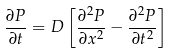Convert formula to latex. <formula><loc_0><loc_0><loc_500><loc_500>\frac { \partial P } { \partial t } = D \left [ \frac { \partial ^ { 2 } P } { \partial x ^ { 2 } } - \frac { \partial ^ { 2 } P } { \partial t ^ { 2 } } \right ]</formula> 